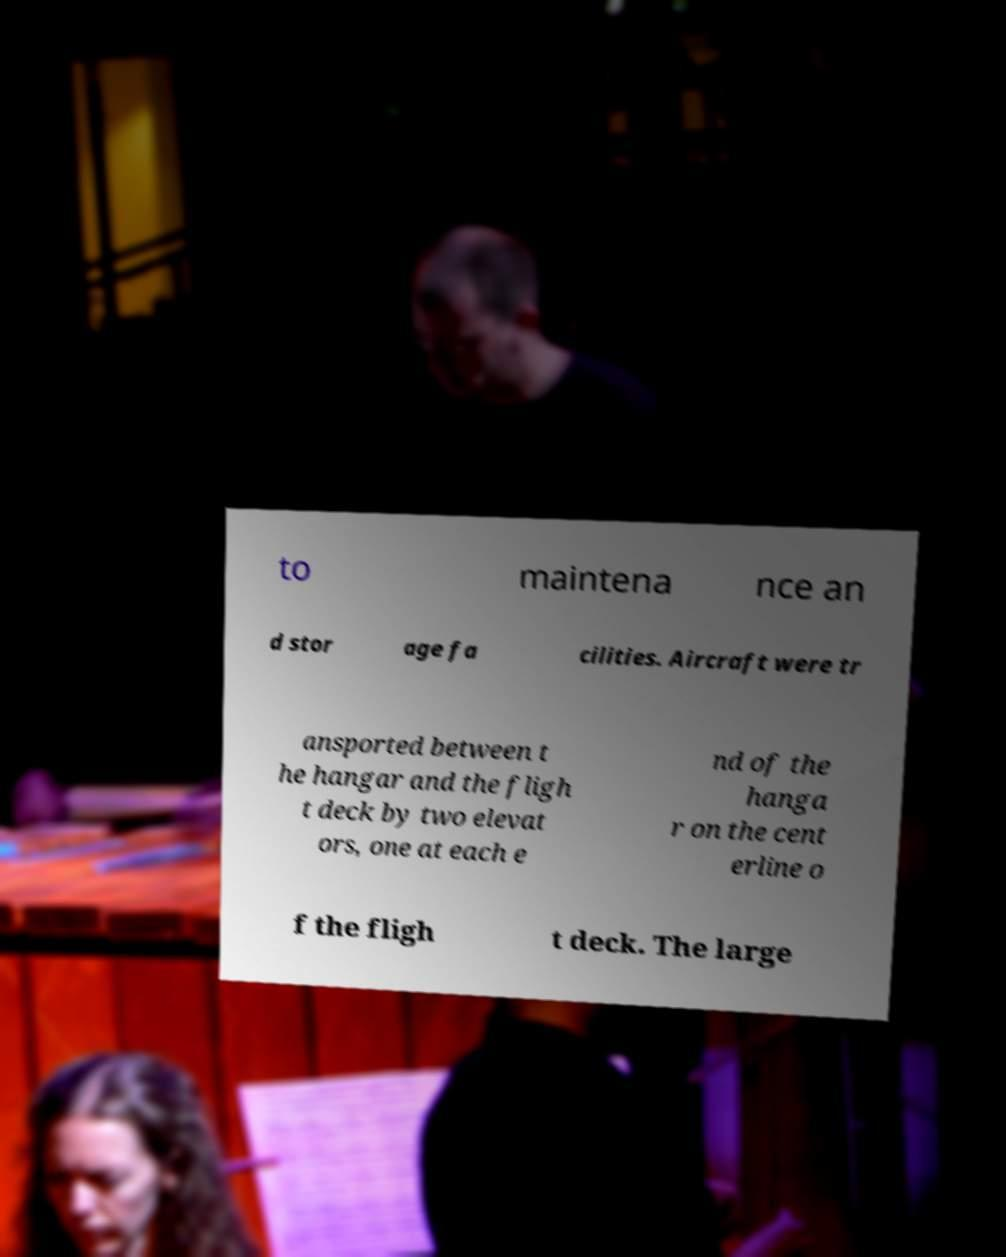Please read and relay the text visible in this image. What does it say? to maintena nce an d stor age fa cilities. Aircraft were tr ansported between t he hangar and the fligh t deck by two elevat ors, one at each e nd of the hanga r on the cent erline o f the fligh t deck. The large 